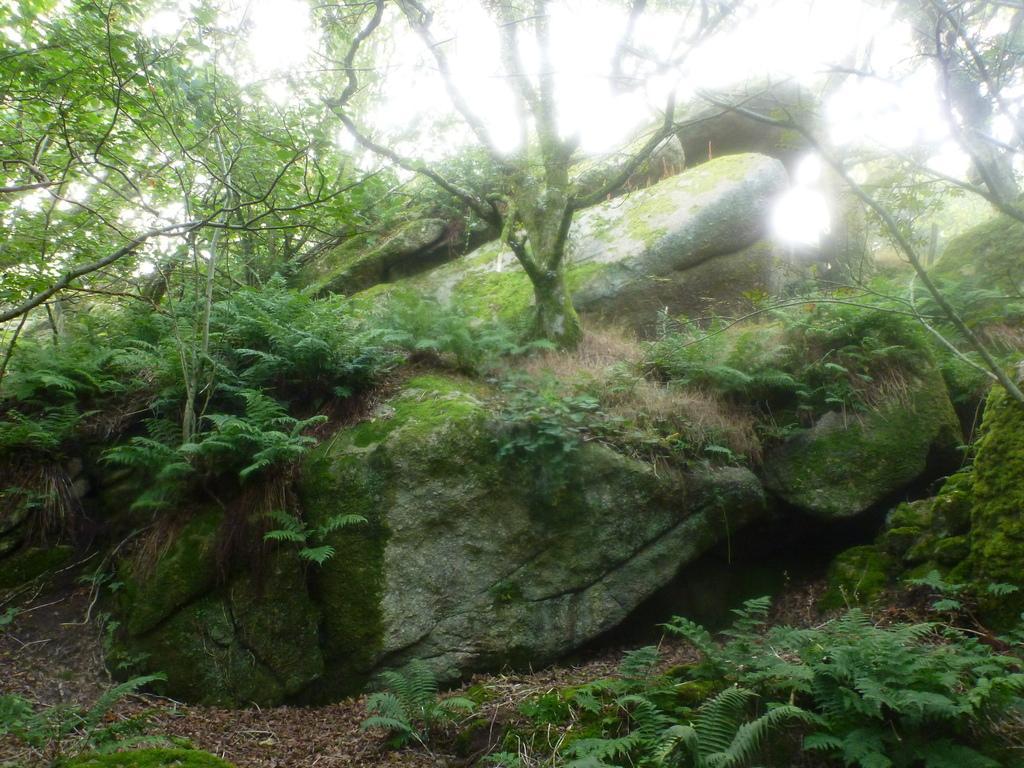Please provide a concise description of this image. In this image there are rocks and trees. At the bottom there are plants. 